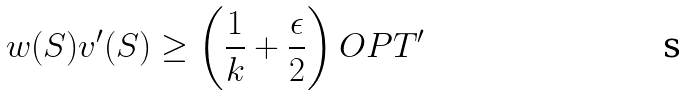Convert formula to latex. <formula><loc_0><loc_0><loc_500><loc_500>w ( S ) v ^ { \prime } ( S ) \geq \left ( \frac { 1 } { k } + \frac { \epsilon } { 2 } \right ) O P T ^ { \prime }</formula> 